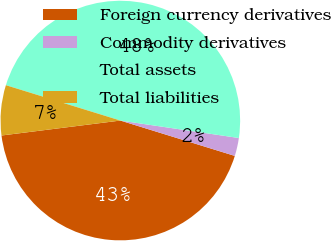<chart> <loc_0><loc_0><loc_500><loc_500><pie_chart><fcel>Foreign currency derivatives<fcel>Commodity derivatives<fcel>Total assets<fcel>Total liabilities<nl><fcel>43.24%<fcel>2.44%<fcel>47.56%<fcel>6.76%<nl></chart> 